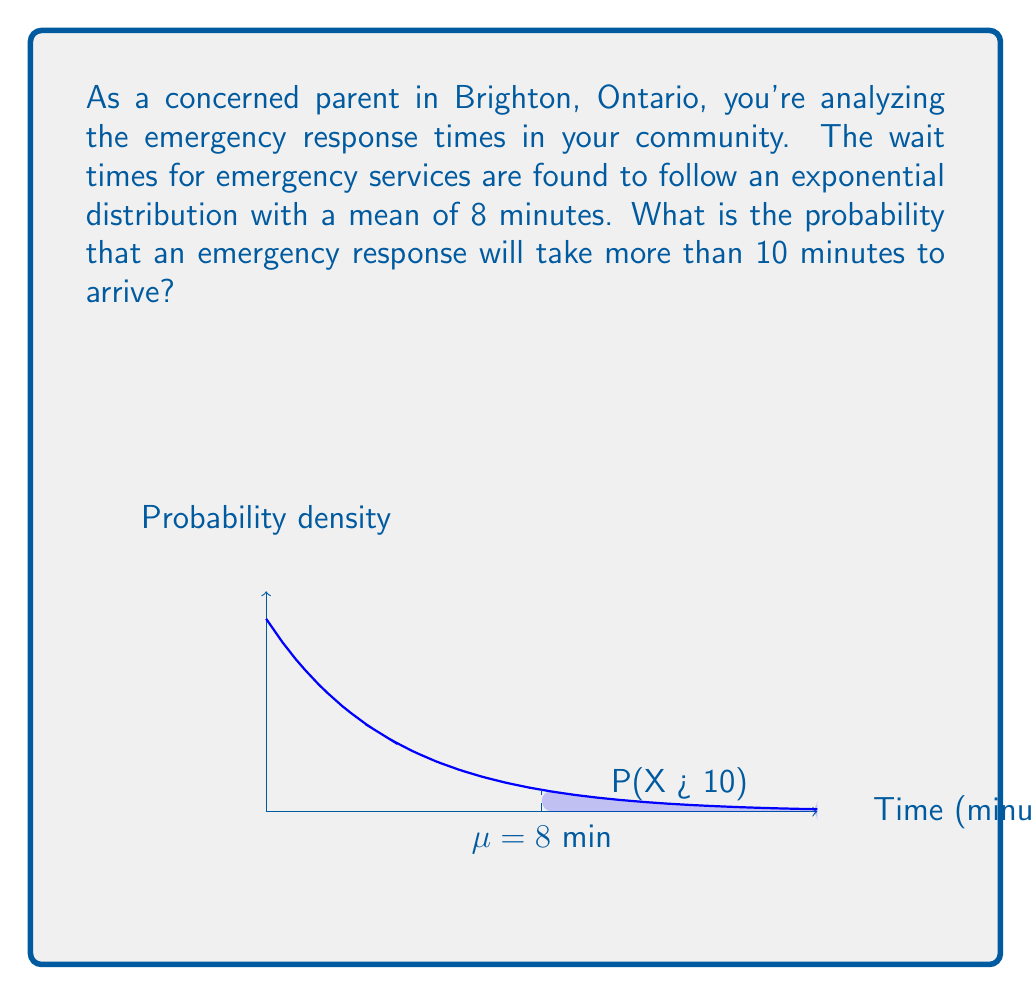Can you answer this question? Let's approach this step-by-step:

1) The exponential distribution has the probability density function:

   $$f(x) = \frac{1}{\mu}e^{-x/\mu}$$

   where $\mu$ is the mean.

2) We're given that the mean wait time $\mu = 8$ minutes.

3) We want to find $P(X > 10)$, where $X$ is the wait time.

4) For the exponential distribution, the probability of waiting longer than a specific time $t$ is given by:

   $$P(X > t) = e^{-t/\mu}$$

5) Substituting our values ($t = 10$, $\mu = 8$):

   $$P(X > 10) = e^{-10/8}$$

6) Let's calculate this:

   $$P(X > 10) = e^{-1.25} \approx 0.2865$$

7) Converting to a percentage:

   $0.2865 \times 100\% \approx 28.65\%$

This means there's about a 28.65% chance that an emergency response will take more than 10 minutes to arrive.
Answer: $28.65\%$ 